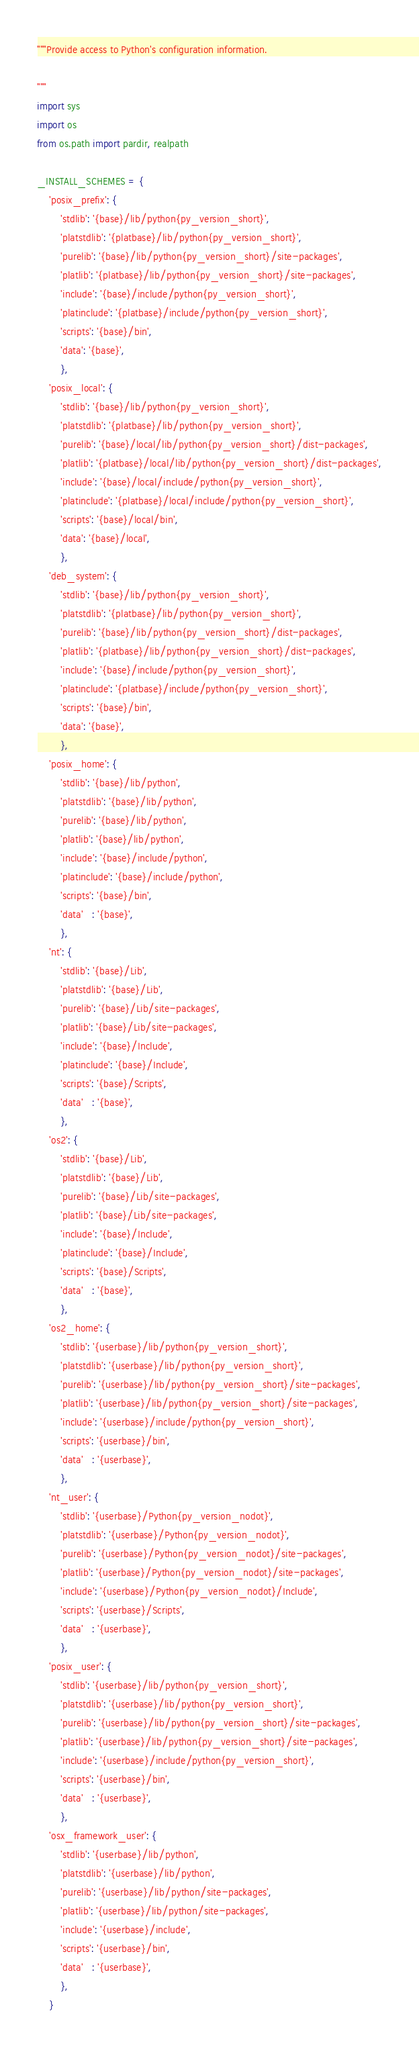<code> <loc_0><loc_0><loc_500><loc_500><_Python_>"""Provide access to Python's configuration information.

"""
import sys
import os
from os.path import pardir, realpath

_INSTALL_SCHEMES = {
    'posix_prefix': {
        'stdlib': '{base}/lib/python{py_version_short}',
        'platstdlib': '{platbase}/lib/python{py_version_short}',
        'purelib': '{base}/lib/python{py_version_short}/site-packages',
        'platlib': '{platbase}/lib/python{py_version_short}/site-packages',
        'include': '{base}/include/python{py_version_short}',
        'platinclude': '{platbase}/include/python{py_version_short}',
        'scripts': '{base}/bin',
        'data': '{base}',
        },
    'posix_local': {
        'stdlib': '{base}/lib/python{py_version_short}',
        'platstdlib': '{platbase}/lib/python{py_version_short}',
        'purelib': '{base}/local/lib/python{py_version_short}/dist-packages',
        'platlib': '{platbase}/local/lib/python{py_version_short}/dist-packages',
        'include': '{base}/local/include/python{py_version_short}',
        'platinclude': '{platbase}/local/include/python{py_version_short}',
        'scripts': '{base}/local/bin',
        'data': '{base}/local',
        },
    'deb_system': {
        'stdlib': '{base}/lib/python{py_version_short}',
        'platstdlib': '{platbase}/lib/python{py_version_short}',
        'purelib': '{base}/lib/python{py_version_short}/dist-packages',
        'platlib': '{platbase}/lib/python{py_version_short}/dist-packages',
        'include': '{base}/include/python{py_version_short}',
        'platinclude': '{platbase}/include/python{py_version_short}',
        'scripts': '{base}/bin',
        'data': '{base}',
        },
    'posix_home': {
        'stdlib': '{base}/lib/python',
        'platstdlib': '{base}/lib/python',
        'purelib': '{base}/lib/python',
        'platlib': '{base}/lib/python',
        'include': '{base}/include/python',
        'platinclude': '{base}/include/python',
        'scripts': '{base}/bin',
        'data'   : '{base}',
        },
    'nt': {
        'stdlib': '{base}/Lib',
        'platstdlib': '{base}/Lib',
        'purelib': '{base}/Lib/site-packages',
        'platlib': '{base}/Lib/site-packages',
        'include': '{base}/Include',
        'platinclude': '{base}/Include',
        'scripts': '{base}/Scripts',
        'data'   : '{base}',
        },
    'os2': {
        'stdlib': '{base}/Lib',
        'platstdlib': '{base}/Lib',
        'purelib': '{base}/Lib/site-packages',
        'platlib': '{base}/Lib/site-packages',
        'include': '{base}/Include',
        'platinclude': '{base}/Include',
        'scripts': '{base}/Scripts',
        'data'   : '{base}',
        },
    'os2_home': {
        'stdlib': '{userbase}/lib/python{py_version_short}',
        'platstdlib': '{userbase}/lib/python{py_version_short}',
        'purelib': '{userbase}/lib/python{py_version_short}/site-packages',
        'platlib': '{userbase}/lib/python{py_version_short}/site-packages',
        'include': '{userbase}/include/python{py_version_short}',
        'scripts': '{userbase}/bin',
        'data'   : '{userbase}',
        },
    'nt_user': {
        'stdlib': '{userbase}/Python{py_version_nodot}',
        'platstdlib': '{userbase}/Python{py_version_nodot}',
        'purelib': '{userbase}/Python{py_version_nodot}/site-packages',
        'platlib': '{userbase}/Python{py_version_nodot}/site-packages',
        'include': '{userbase}/Python{py_version_nodot}/Include',
        'scripts': '{userbase}/Scripts',
        'data'   : '{userbase}',
        },
    'posix_user': {
        'stdlib': '{userbase}/lib/python{py_version_short}',
        'platstdlib': '{userbase}/lib/python{py_version_short}',
        'purelib': '{userbase}/lib/python{py_version_short}/site-packages',
        'platlib': '{userbase}/lib/python{py_version_short}/site-packages',
        'include': '{userbase}/include/python{py_version_short}',
        'scripts': '{userbase}/bin',
        'data'   : '{userbase}',
        },
    'osx_framework_user': {
        'stdlib': '{userbase}/lib/python',
        'platstdlib': '{userbase}/lib/python',
        'purelib': '{userbase}/lib/python/site-packages',
        'platlib': '{userbase}/lib/python/site-packages',
        'include': '{userbase}/include',
        'scripts': '{userbase}/bin',
        'data'   : '{userbase}',
        },
    }
</code> 